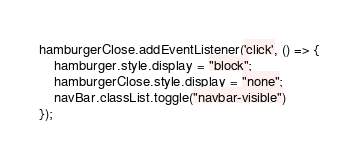Convert code to text. <code><loc_0><loc_0><loc_500><loc_500><_JavaScript_>hamburgerClose.addEventListener('click', () => {
    hamburger.style.display = "block";
    hamburgerClose.style.display = "none";
    navBar.classList.toggle("navbar-visible")
});</code> 